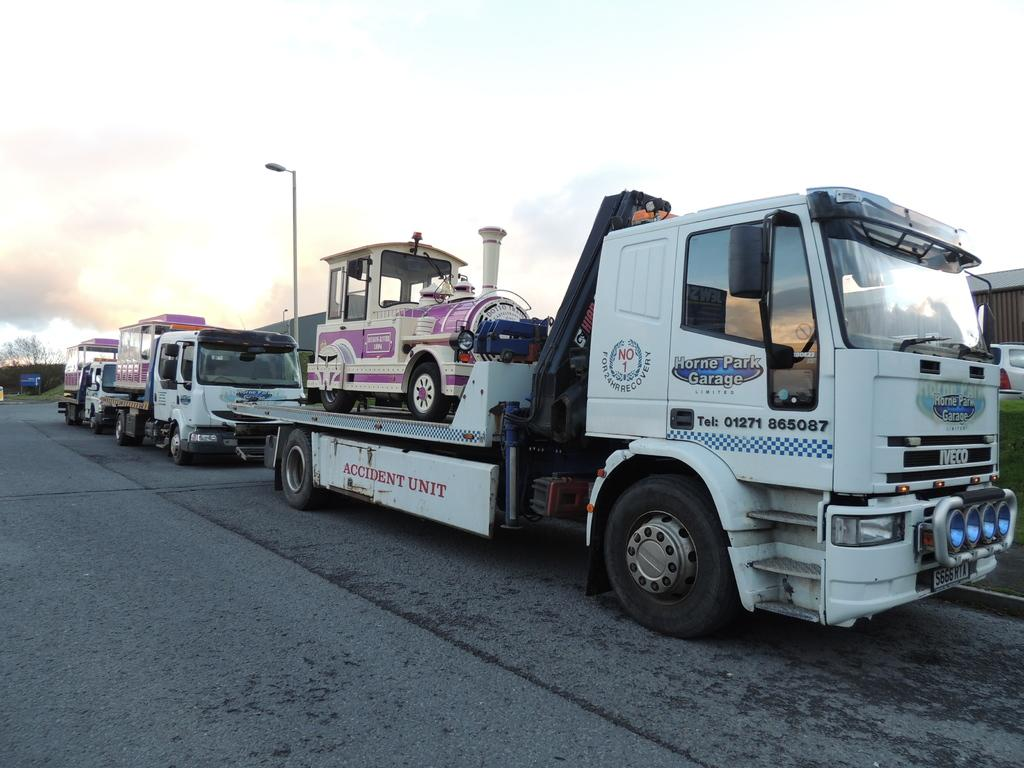What are the trucks carrying in the image? The trucks are carrying vehicles in the image. What type of structures can be seen in the image? There are buildings visible in the image. What type of vehicle is present in the image? There is a car in the image. What type of vegetation is present in the image? Trees are present in the image. How would you describe the weather in the image? The sky is cloudy in the image, suggesting a potentially overcast or rainy day. What type of dress is hanging on the tree in the image? There is no dress present in the image; it features trucks carrying vehicles, buildings, a car, trees, and a cloudy sky. What date is marked on the calendar in the image? There is no calendar present in the image. 